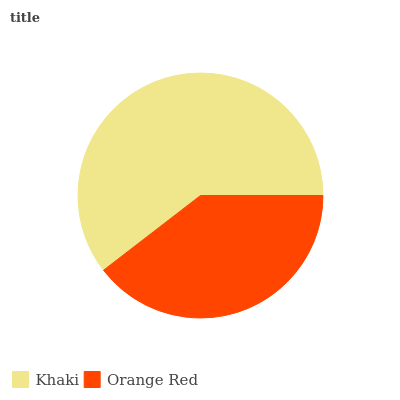Is Orange Red the minimum?
Answer yes or no. Yes. Is Khaki the maximum?
Answer yes or no. Yes. Is Orange Red the maximum?
Answer yes or no. No. Is Khaki greater than Orange Red?
Answer yes or no. Yes. Is Orange Red less than Khaki?
Answer yes or no. Yes. Is Orange Red greater than Khaki?
Answer yes or no. No. Is Khaki less than Orange Red?
Answer yes or no. No. Is Khaki the high median?
Answer yes or no. Yes. Is Orange Red the low median?
Answer yes or no. Yes. Is Orange Red the high median?
Answer yes or no. No. Is Khaki the low median?
Answer yes or no. No. 